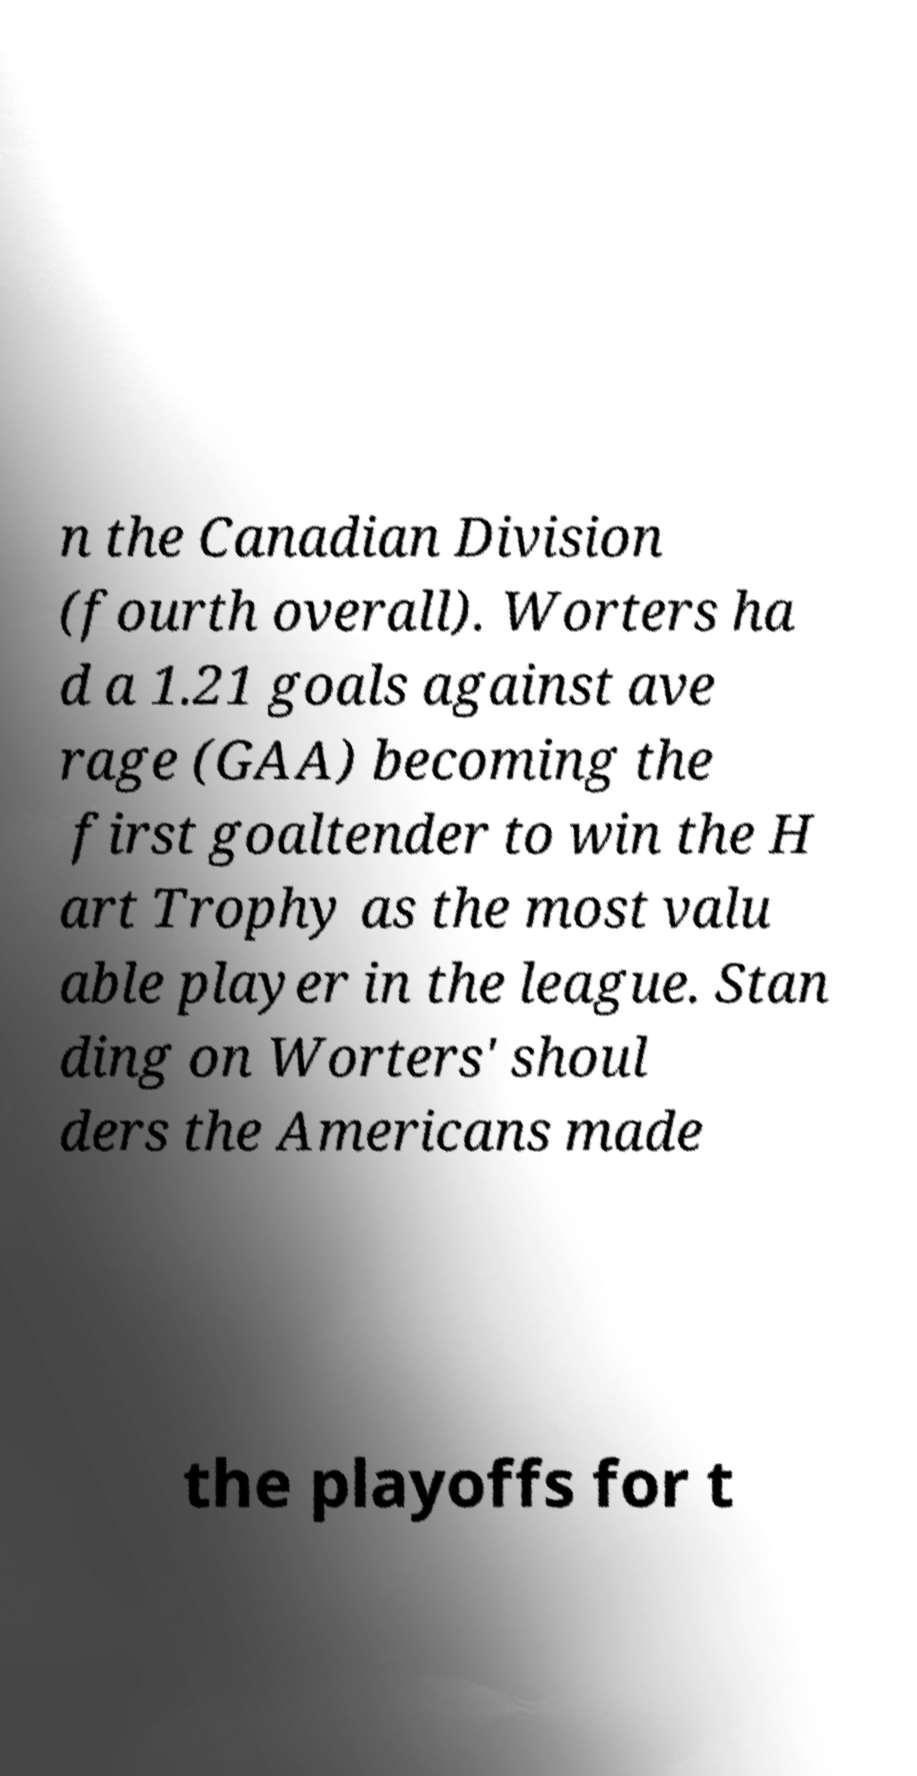Please identify and transcribe the text found in this image. n the Canadian Division (fourth overall). Worters ha d a 1.21 goals against ave rage (GAA) becoming the first goaltender to win the H art Trophy as the most valu able player in the league. Stan ding on Worters' shoul ders the Americans made the playoffs for t 